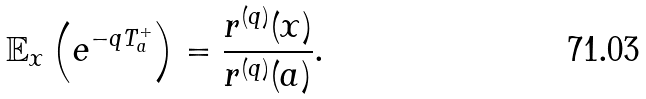Convert formula to latex. <formula><loc_0><loc_0><loc_500><loc_500>\mathbb { E } _ { x } \left ( e ^ { - q T _ { a } ^ { + } } \right ) = \frac { r ^ { ( q ) } ( x ) } { r ^ { ( q ) } ( a ) } .</formula> 